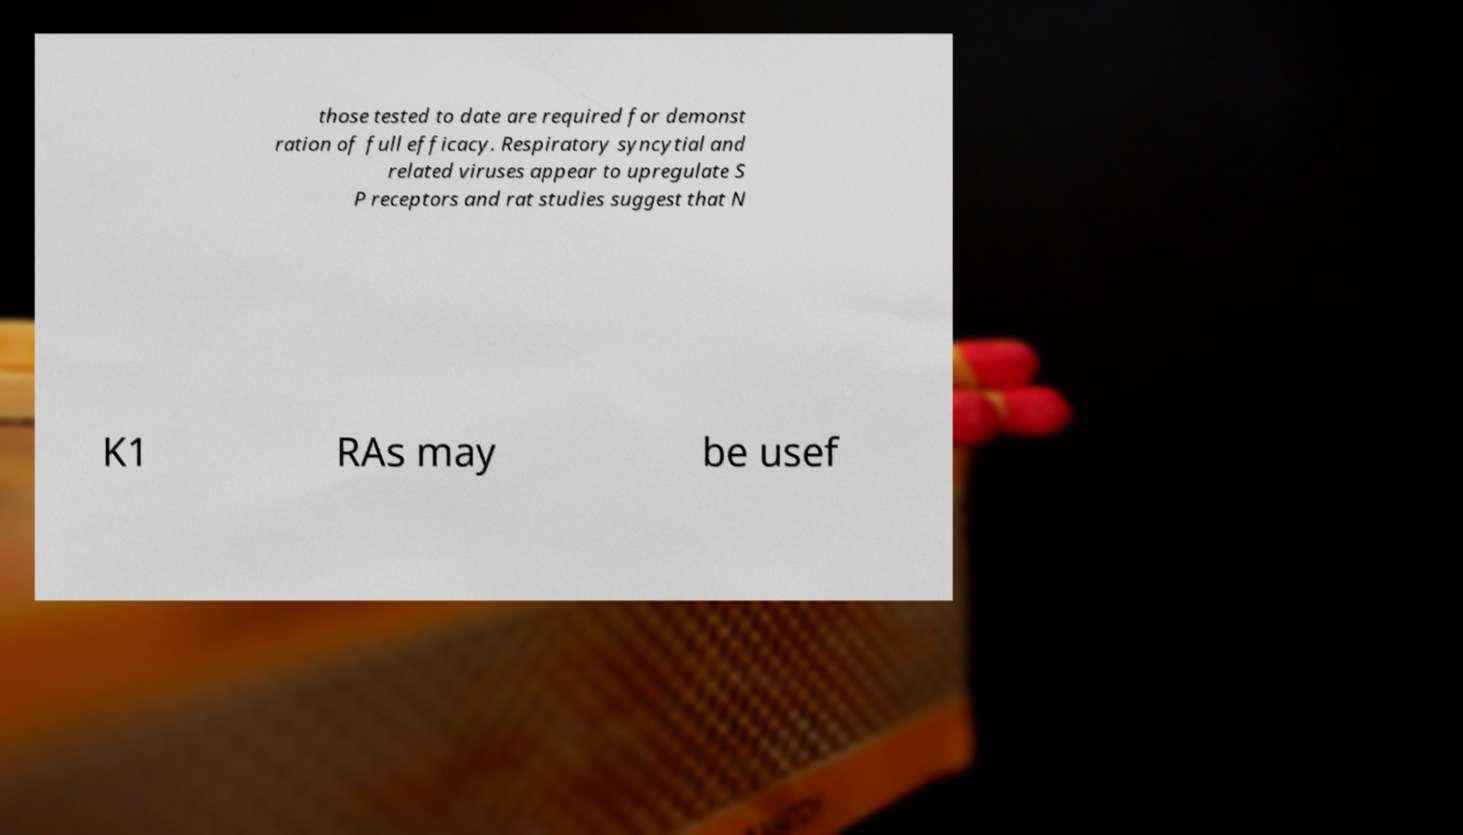Can you read and provide the text displayed in the image?This photo seems to have some interesting text. Can you extract and type it out for me? those tested to date are required for demonst ration of full efficacy. Respiratory syncytial and related viruses appear to upregulate S P receptors and rat studies suggest that N K1 RAs may be usef 